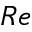<formula> <loc_0><loc_0><loc_500><loc_500>R e</formula> 